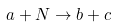Convert formula to latex. <formula><loc_0><loc_0><loc_500><loc_500>a + N \rightarrow b + c</formula> 